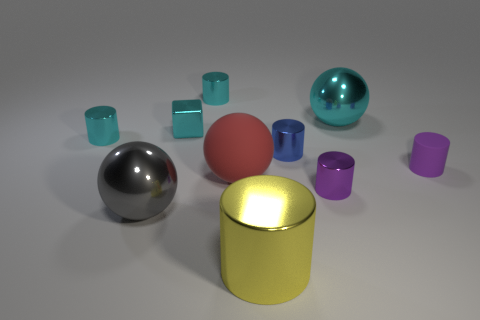Subtract all yellow cylinders. How many cylinders are left? 5 Subtract all yellow cylinders. How many cylinders are left? 5 Subtract 1 cylinders. How many cylinders are left? 5 Subtract all green cylinders. Subtract all yellow cubes. How many cylinders are left? 6 Subtract all cylinders. How many objects are left? 4 Add 5 tiny cyan metal objects. How many tiny cyan metal objects are left? 8 Add 2 big red balls. How many big red balls exist? 3 Subtract 0 blue blocks. How many objects are left? 10 Subtract all gray things. Subtract all balls. How many objects are left? 6 